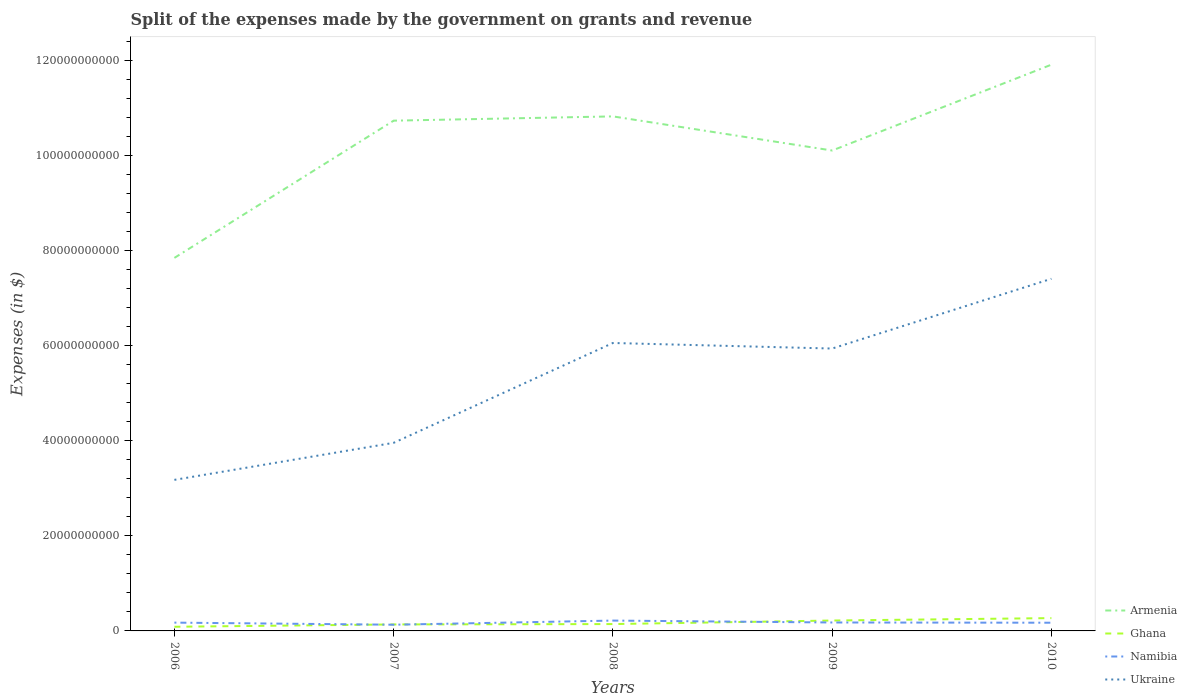Across all years, what is the maximum expenses made by the government on grants and revenue in Armenia?
Offer a very short reply. 7.84e+1. In which year was the expenses made by the government on grants and revenue in Armenia maximum?
Ensure brevity in your answer.  2006. What is the total expenses made by the government on grants and revenue in Ukraine in the graph?
Keep it short and to the point. -7.79e+09. What is the difference between the highest and the second highest expenses made by the government on grants and revenue in Namibia?
Make the answer very short. 8.70e+08. What is the difference between the highest and the lowest expenses made by the government on grants and revenue in Ukraine?
Provide a short and direct response. 3. Is the expenses made by the government on grants and revenue in Ghana strictly greater than the expenses made by the government on grants and revenue in Namibia over the years?
Make the answer very short. No. What is the difference between two consecutive major ticks on the Y-axis?
Offer a terse response. 2.00e+1. Does the graph contain any zero values?
Keep it short and to the point. No. How many legend labels are there?
Ensure brevity in your answer.  4. What is the title of the graph?
Offer a very short reply. Split of the expenses made by the government on grants and revenue. Does "Serbia" appear as one of the legend labels in the graph?
Offer a terse response. No. What is the label or title of the Y-axis?
Your response must be concise. Expenses (in $). What is the Expenses (in $) in Armenia in 2006?
Your response must be concise. 7.84e+1. What is the Expenses (in $) of Ghana in 2006?
Offer a very short reply. 8.75e+08. What is the Expenses (in $) in Namibia in 2006?
Keep it short and to the point. 1.75e+09. What is the Expenses (in $) in Ukraine in 2006?
Your response must be concise. 3.18e+1. What is the Expenses (in $) of Armenia in 2007?
Provide a succinct answer. 1.07e+11. What is the Expenses (in $) of Ghana in 2007?
Your response must be concise. 1.36e+09. What is the Expenses (in $) of Namibia in 2007?
Your response must be concise. 1.30e+09. What is the Expenses (in $) in Ukraine in 2007?
Keep it short and to the point. 3.95e+1. What is the Expenses (in $) of Armenia in 2008?
Keep it short and to the point. 1.08e+11. What is the Expenses (in $) in Ghana in 2008?
Make the answer very short. 1.44e+09. What is the Expenses (in $) in Namibia in 2008?
Give a very brief answer. 2.17e+09. What is the Expenses (in $) in Ukraine in 2008?
Your answer should be very brief. 6.05e+1. What is the Expenses (in $) in Armenia in 2009?
Give a very brief answer. 1.01e+11. What is the Expenses (in $) of Ghana in 2009?
Keep it short and to the point. 2.19e+09. What is the Expenses (in $) in Namibia in 2009?
Your response must be concise. 1.77e+09. What is the Expenses (in $) of Ukraine in 2009?
Keep it short and to the point. 5.94e+1. What is the Expenses (in $) of Armenia in 2010?
Keep it short and to the point. 1.19e+11. What is the Expenses (in $) in Ghana in 2010?
Make the answer very short. 2.69e+09. What is the Expenses (in $) in Namibia in 2010?
Your answer should be very brief. 1.72e+09. What is the Expenses (in $) in Ukraine in 2010?
Provide a succinct answer. 7.40e+1. Across all years, what is the maximum Expenses (in $) in Armenia?
Make the answer very short. 1.19e+11. Across all years, what is the maximum Expenses (in $) of Ghana?
Your answer should be compact. 2.69e+09. Across all years, what is the maximum Expenses (in $) in Namibia?
Provide a short and direct response. 2.17e+09. Across all years, what is the maximum Expenses (in $) in Ukraine?
Make the answer very short. 7.40e+1. Across all years, what is the minimum Expenses (in $) of Armenia?
Ensure brevity in your answer.  7.84e+1. Across all years, what is the minimum Expenses (in $) of Ghana?
Offer a very short reply. 8.75e+08. Across all years, what is the minimum Expenses (in $) in Namibia?
Ensure brevity in your answer.  1.30e+09. Across all years, what is the minimum Expenses (in $) of Ukraine?
Your response must be concise. 3.18e+1. What is the total Expenses (in $) in Armenia in the graph?
Provide a succinct answer. 5.14e+11. What is the total Expenses (in $) of Ghana in the graph?
Make the answer very short. 8.56e+09. What is the total Expenses (in $) in Namibia in the graph?
Ensure brevity in your answer.  8.72e+09. What is the total Expenses (in $) in Ukraine in the graph?
Give a very brief answer. 2.65e+11. What is the difference between the Expenses (in $) in Armenia in 2006 and that in 2007?
Provide a succinct answer. -2.89e+1. What is the difference between the Expenses (in $) in Ghana in 2006 and that in 2007?
Keep it short and to the point. -4.88e+08. What is the difference between the Expenses (in $) in Namibia in 2006 and that in 2007?
Keep it short and to the point. 4.41e+08. What is the difference between the Expenses (in $) of Ukraine in 2006 and that in 2007?
Make the answer very short. -7.79e+09. What is the difference between the Expenses (in $) in Armenia in 2006 and that in 2008?
Your answer should be very brief. -2.98e+1. What is the difference between the Expenses (in $) of Ghana in 2006 and that in 2008?
Ensure brevity in your answer.  -5.66e+08. What is the difference between the Expenses (in $) in Namibia in 2006 and that in 2008?
Provide a succinct answer. -4.29e+08. What is the difference between the Expenses (in $) in Ukraine in 2006 and that in 2008?
Offer a very short reply. -2.88e+1. What is the difference between the Expenses (in $) in Armenia in 2006 and that in 2009?
Offer a terse response. -2.26e+1. What is the difference between the Expenses (in $) in Ghana in 2006 and that in 2009?
Ensure brevity in your answer.  -1.31e+09. What is the difference between the Expenses (in $) in Namibia in 2006 and that in 2009?
Ensure brevity in your answer.  -2.82e+07. What is the difference between the Expenses (in $) of Ukraine in 2006 and that in 2009?
Keep it short and to the point. -2.76e+1. What is the difference between the Expenses (in $) in Armenia in 2006 and that in 2010?
Keep it short and to the point. -4.06e+1. What is the difference between the Expenses (in $) of Ghana in 2006 and that in 2010?
Your response must be concise. -1.82e+09. What is the difference between the Expenses (in $) in Namibia in 2006 and that in 2010?
Offer a terse response. 2.13e+07. What is the difference between the Expenses (in $) in Ukraine in 2006 and that in 2010?
Give a very brief answer. -4.23e+1. What is the difference between the Expenses (in $) of Armenia in 2007 and that in 2008?
Provide a short and direct response. -8.98e+08. What is the difference between the Expenses (in $) in Ghana in 2007 and that in 2008?
Offer a very short reply. -7.78e+07. What is the difference between the Expenses (in $) of Namibia in 2007 and that in 2008?
Offer a very short reply. -8.70e+08. What is the difference between the Expenses (in $) in Ukraine in 2007 and that in 2008?
Offer a terse response. -2.10e+1. What is the difference between the Expenses (in $) of Armenia in 2007 and that in 2009?
Provide a succinct answer. 6.28e+09. What is the difference between the Expenses (in $) of Ghana in 2007 and that in 2009?
Provide a short and direct response. -8.24e+08. What is the difference between the Expenses (in $) in Namibia in 2007 and that in 2009?
Provide a succinct answer. -4.69e+08. What is the difference between the Expenses (in $) of Ukraine in 2007 and that in 2009?
Provide a succinct answer. -1.98e+1. What is the difference between the Expenses (in $) of Armenia in 2007 and that in 2010?
Provide a succinct answer. -1.18e+1. What is the difference between the Expenses (in $) in Ghana in 2007 and that in 2010?
Provide a short and direct response. -1.33e+09. What is the difference between the Expenses (in $) in Namibia in 2007 and that in 2010?
Provide a succinct answer. -4.20e+08. What is the difference between the Expenses (in $) of Ukraine in 2007 and that in 2010?
Offer a terse response. -3.45e+1. What is the difference between the Expenses (in $) in Armenia in 2008 and that in 2009?
Offer a terse response. 7.18e+09. What is the difference between the Expenses (in $) in Ghana in 2008 and that in 2009?
Keep it short and to the point. -7.46e+08. What is the difference between the Expenses (in $) of Namibia in 2008 and that in 2009?
Provide a succinct answer. 4.01e+08. What is the difference between the Expenses (in $) of Ukraine in 2008 and that in 2009?
Make the answer very short. 1.17e+09. What is the difference between the Expenses (in $) in Armenia in 2008 and that in 2010?
Offer a terse response. -1.09e+1. What is the difference between the Expenses (in $) of Ghana in 2008 and that in 2010?
Your answer should be very brief. -1.25e+09. What is the difference between the Expenses (in $) in Namibia in 2008 and that in 2010?
Offer a terse response. 4.50e+08. What is the difference between the Expenses (in $) in Ukraine in 2008 and that in 2010?
Your answer should be very brief. -1.35e+1. What is the difference between the Expenses (in $) in Armenia in 2009 and that in 2010?
Give a very brief answer. -1.80e+1. What is the difference between the Expenses (in $) of Ghana in 2009 and that in 2010?
Make the answer very short. -5.08e+08. What is the difference between the Expenses (in $) in Namibia in 2009 and that in 2010?
Offer a very short reply. 4.94e+07. What is the difference between the Expenses (in $) in Ukraine in 2009 and that in 2010?
Your answer should be compact. -1.47e+1. What is the difference between the Expenses (in $) of Armenia in 2006 and the Expenses (in $) of Ghana in 2007?
Keep it short and to the point. 7.71e+1. What is the difference between the Expenses (in $) of Armenia in 2006 and the Expenses (in $) of Namibia in 2007?
Your answer should be very brief. 7.71e+1. What is the difference between the Expenses (in $) of Armenia in 2006 and the Expenses (in $) of Ukraine in 2007?
Offer a terse response. 3.89e+1. What is the difference between the Expenses (in $) of Ghana in 2006 and the Expenses (in $) of Namibia in 2007?
Provide a short and direct response. -4.30e+08. What is the difference between the Expenses (in $) in Ghana in 2006 and the Expenses (in $) in Ukraine in 2007?
Your answer should be very brief. -3.87e+1. What is the difference between the Expenses (in $) in Namibia in 2006 and the Expenses (in $) in Ukraine in 2007?
Make the answer very short. -3.78e+1. What is the difference between the Expenses (in $) of Armenia in 2006 and the Expenses (in $) of Ghana in 2008?
Your answer should be very brief. 7.70e+1. What is the difference between the Expenses (in $) of Armenia in 2006 and the Expenses (in $) of Namibia in 2008?
Offer a terse response. 7.63e+1. What is the difference between the Expenses (in $) of Armenia in 2006 and the Expenses (in $) of Ukraine in 2008?
Ensure brevity in your answer.  1.79e+1. What is the difference between the Expenses (in $) of Ghana in 2006 and the Expenses (in $) of Namibia in 2008?
Provide a short and direct response. -1.30e+09. What is the difference between the Expenses (in $) in Ghana in 2006 and the Expenses (in $) in Ukraine in 2008?
Your answer should be compact. -5.97e+1. What is the difference between the Expenses (in $) of Namibia in 2006 and the Expenses (in $) of Ukraine in 2008?
Your response must be concise. -5.88e+1. What is the difference between the Expenses (in $) of Armenia in 2006 and the Expenses (in $) of Ghana in 2009?
Provide a succinct answer. 7.62e+1. What is the difference between the Expenses (in $) of Armenia in 2006 and the Expenses (in $) of Namibia in 2009?
Ensure brevity in your answer.  7.67e+1. What is the difference between the Expenses (in $) of Armenia in 2006 and the Expenses (in $) of Ukraine in 2009?
Ensure brevity in your answer.  1.91e+1. What is the difference between the Expenses (in $) in Ghana in 2006 and the Expenses (in $) in Namibia in 2009?
Offer a very short reply. -8.99e+08. What is the difference between the Expenses (in $) in Ghana in 2006 and the Expenses (in $) in Ukraine in 2009?
Your answer should be very brief. -5.85e+1. What is the difference between the Expenses (in $) in Namibia in 2006 and the Expenses (in $) in Ukraine in 2009?
Your response must be concise. -5.76e+1. What is the difference between the Expenses (in $) in Armenia in 2006 and the Expenses (in $) in Ghana in 2010?
Ensure brevity in your answer.  7.57e+1. What is the difference between the Expenses (in $) of Armenia in 2006 and the Expenses (in $) of Namibia in 2010?
Offer a very short reply. 7.67e+1. What is the difference between the Expenses (in $) in Armenia in 2006 and the Expenses (in $) in Ukraine in 2010?
Your answer should be compact. 4.39e+09. What is the difference between the Expenses (in $) in Ghana in 2006 and the Expenses (in $) in Namibia in 2010?
Provide a short and direct response. -8.50e+08. What is the difference between the Expenses (in $) in Ghana in 2006 and the Expenses (in $) in Ukraine in 2010?
Ensure brevity in your answer.  -7.32e+1. What is the difference between the Expenses (in $) in Namibia in 2006 and the Expenses (in $) in Ukraine in 2010?
Offer a terse response. -7.23e+1. What is the difference between the Expenses (in $) in Armenia in 2007 and the Expenses (in $) in Ghana in 2008?
Ensure brevity in your answer.  1.06e+11. What is the difference between the Expenses (in $) in Armenia in 2007 and the Expenses (in $) in Namibia in 2008?
Make the answer very short. 1.05e+11. What is the difference between the Expenses (in $) in Armenia in 2007 and the Expenses (in $) in Ukraine in 2008?
Your response must be concise. 4.67e+1. What is the difference between the Expenses (in $) of Ghana in 2007 and the Expenses (in $) of Namibia in 2008?
Make the answer very short. -8.12e+08. What is the difference between the Expenses (in $) of Ghana in 2007 and the Expenses (in $) of Ukraine in 2008?
Your response must be concise. -5.92e+1. What is the difference between the Expenses (in $) of Namibia in 2007 and the Expenses (in $) of Ukraine in 2008?
Give a very brief answer. -5.92e+1. What is the difference between the Expenses (in $) of Armenia in 2007 and the Expenses (in $) of Ghana in 2009?
Your answer should be very brief. 1.05e+11. What is the difference between the Expenses (in $) in Armenia in 2007 and the Expenses (in $) in Namibia in 2009?
Your answer should be compact. 1.06e+11. What is the difference between the Expenses (in $) of Armenia in 2007 and the Expenses (in $) of Ukraine in 2009?
Make the answer very short. 4.79e+1. What is the difference between the Expenses (in $) in Ghana in 2007 and the Expenses (in $) in Namibia in 2009?
Your answer should be compact. -4.11e+08. What is the difference between the Expenses (in $) in Ghana in 2007 and the Expenses (in $) in Ukraine in 2009?
Offer a terse response. -5.80e+1. What is the difference between the Expenses (in $) of Namibia in 2007 and the Expenses (in $) of Ukraine in 2009?
Make the answer very short. -5.81e+1. What is the difference between the Expenses (in $) of Armenia in 2007 and the Expenses (in $) of Ghana in 2010?
Your response must be concise. 1.05e+11. What is the difference between the Expenses (in $) in Armenia in 2007 and the Expenses (in $) in Namibia in 2010?
Your response must be concise. 1.06e+11. What is the difference between the Expenses (in $) in Armenia in 2007 and the Expenses (in $) in Ukraine in 2010?
Offer a terse response. 3.32e+1. What is the difference between the Expenses (in $) of Ghana in 2007 and the Expenses (in $) of Namibia in 2010?
Provide a succinct answer. -3.61e+08. What is the difference between the Expenses (in $) of Ghana in 2007 and the Expenses (in $) of Ukraine in 2010?
Offer a very short reply. -7.27e+1. What is the difference between the Expenses (in $) in Namibia in 2007 and the Expenses (in $) in Ukraine in 2010?
Offer a very short reply. -7.27e+1. What is the difference between the Expenses (in $) in Armenia in 2008 and the Expenses (in $) in Ghana in 2009?
Your answer should be very brief. 1.06e+11. What is the difference between the Expenses (in $) of Armenia in 2008 and the Expenses (in $) of Namibia in 2009?
Ensure brevity in your answer.  1.06e+11. What is the difference between the Expenses (in $) in Armenia in 2008 and the Expenses (in $) in Ukraine in 2009?
Your answer should be compact. 4.88e+1. What is the difference between the Expenses (in $) of Ghana in 2008 and the Expenses (in $) of Namibia in 2009?
Offer a very short reply. -3.33e+08. What is the difference between the Expenses (in $) in Ghana in 2008 and the Expenses (in $) in Ukraine in 2009?
Your answer should be compact. -5.79e+1. What is the difference between the Expenses (in $) of Namibia in 2008 and the Expenses (in $) of Ukraine in 2009?
Keep it short and to the point. -5.72e+1. What is the difference between the Expenses (in $) in Armenia in 2008 and the Expenses (in $) in Ghana in 2010?
Ensure brevity in your answer.  1.05e+11. What is the difference between the Expenses (in $) of Armenia in 2008 and the Expenses (in $) of Namibia in 2010?
Your answer should be compact. 1.06e+11. What is the difference between the Expenses (in $) of Armenia in 2008 and the Expenses (in $) of Ukraine in 2010?
Provide a short and direct response. 3.41e+1. What is the difference between the Expenses (in $) of Ghana in 2008 and the Expenses (in $) of Namibia in 2010?
Offer a terse response. -2.83e+08. What is the difference between the Expenses (in $) in Ghana in 2008 and the Expenses (in $) in Ukraine in 2010?
Provide a succinct answer. -7.26e+1. What is the difference between the Expenses (in $) of Namibia in 2008 and the Expenses (in $) of Ukraine in 2010?
Your response must be concise. -7.19e+1. What is the difference between the Expenses (in $) of Armenia in 2009 and the Expenses (in $) of Ghana in 2010?
Keep it short and to the point. 9.83e+1. What is the difference between the Expenses (in $) in Armenia in 2009 and the Expenses (in $) in Namibia in 2010?
Your answer should be very brief. 9.93e+1. What is the difference between the Expenses (in $) in Armenia in 2009 and the Expenses (in $) in Ukraine in 2010?
Provide a short and direct response. 2.70e+1. What is the difference between the Expenses (in $) of Ghana in 2009 and the Expenses (in $) of Namibia in 2010?
Your answer should be very brief. 4.62e+08. What is the difference between the Expenses (in $) of Ghana in 2009 and the Expenses (in $) of Ukraine in 2010?
Your response must be concise. -7.19e+1. What is the difference between the Expenses (in $) of Namibia in 2009 and the Expenses (in $) of Ukraine in 2010?
Provide a short and direct response. -7.23e+1. What is the average Expenses (in $) in Armenia per year?
Offer a very short reply. 1.03e+11. What is the average Expenses (in $) of Ghana per year?
Your answer should be compact. 1.71e+09. What is the average Expenses (in $) in Namibia per year?
Offer a very short reply. 1.74e+09. What is the average Expenses (in $) of Ukraine per year?
Make the answer very short. 5.31e+1. In the year 2006, what is the difference between the Expenses (in $) in Armenia and Expenses (in $) in Ghana?
Offer a terse response. 7.76e+1. In the year 2006, what is the difference between the Expenses (in $) of Armenia and Expenses (in $) of Namibia?
Give a very brief answer. 7.67e+1. In the year 2006, what is the difference between the Expenses (in $) of Armenia and Expenses (in $) of Ukraine?
Make the answer very short. 4.67e+1. In the year 2006, what is the difference between the Expenses (in $) of Ghana and Expenses (in $) of Namibia?
Provide a succinct answer. -8.71e+08. In the year 2006, what is the difference between the Expenses (in $) of Ghana and Expenses (in $) of Ukraine?
Make the answer very short. -3.09e+1. In the year 2006, what is the difference between the Expenses (in $) in Namibia and Expenses (in $) in Ukraine?
Offer a very short reply. -3.00e+1. In the year 2007, what is the difference between the Expenses (in $) in Armenia and Expenses (in $) in Ghana?
Provide a short and direct response. 1.06e+11. In the year 2007, what is the difference between the Expenses (in $) in Armenia and Expenses (in $) in Namibia?
Provide a short and direct response. 1.06e+11. In the year 2007, what is the difference between the Expenses (in $) of Armenia and Expenses (in $) of Ukraine?
Make the answer very short. 6.77e+1. In the year 2007, what is the difference between the Expenses (in $) of Ghana and Expenses (in $) of Namibia?
Provide a succinct answer. 5.83e+07. In the year 2007, what is the difference between the Expenses (in $) of Ghana and Expenses (in $) of Ukraine?
Your answer should be very brief. -3.82e+1. In the year 2007, what is the difference between the Expenses (in $) of Namibia and Expenses (in $) of Ukraine?
Give a very brief answer. -3.82e+1. In the year 2008, what is the difference between the Expenses (in $) of Armenia and Expenses (in $) of Ghana?
Provide a short and direct response. 1.07e+11. In the year 2008, what is the difference between the Expenses (in $) in Armenia and Expenses (in $) in Namibia?
Ensure brevity in your answer.  1.06e+11. In the year 2008, what is the difference between the Expenses (in $) of Armenia and Expenses (in $) of Ukraine?
Your answer should be very brief. 4.76e+1. In the year 2008, what is the difference between the Expenses (in $) in Ghana and Expenses (in $) in Namibia?
Keep it short and to the point. -7.34e+08. In the year 2008, what is the difference between the Expenses (in $) of Ghana and Expenses (in $) of Ukraine?
Offer a terse response. -5.91e+1. In the year 2008, what is the difference between the Expenses (in $) in Namibia and Expenses (in $) in Ukraine?
Make the answer very short. -5.84e+1. In the year 2009, what is the difference between the Expenses (in $) of Armenia and Expenses (in $) of Ghana?
Give a very brief answer. 9.88e+1. In the year 2009, what is the difference between the Expenses (in $) of Armenia and Expenses (in $) of Namibia?
Your answer should be very brief. 9.92e+1. In the year 2009, what is the difference between the Expenses (in $) in Armenia and Expenses (in $) in Ukraine?
Give a very brief answer. 4.16e+1. In the year 2009, what is the difference between the Expenses (in $) of Ghana and Expenses (in $) of Namibia?
Your response must be concise. 4.13e+08. In the year 2009, what is the difference between the Expenses (in $) in Ghana and Expenses (in $) in Ukraine?
Your answer should be very brief. -5.72e+1. In the year 2009, what is the difference between the Expenses (in $) of Namibia and Expenses (in $) of Ukraine?
Give a very brief answer. -5.76e+1. In the year 2010, what is the difference between the Expenses (in $) in Armenia and Expenses (in $) in Ghana?
Provide a succinct answer. 1.16e+11. In the year 2010, what is the difference between the Expenses (in $) of Armenia and Expenses (in $) of Namibia?
Provide a succinct answer. 1.17e+11. In the year 2010, what is the difference between the Expenses (in $) in Armenia and Expenses (in $) in Ukraine?
Provide a short and direct response. 4.50e+1. In the year 2010, what is the difference between the Expenses (in $) in Ghana and Expenses (in $) in Namibia?
Make the answer very short. 9.70e+08. In the year 2010, what is the difference between the Expenses (in $) of Ghana and Expenses (in $) of Ukraine?
Ensure brevity in your answer.  -7.13e+1. In the year 2010, what is the difference between the Expenses (in $) of Namibia and Expenses (in $) of Ukraine?
Offer a terse response. -7.23e+1. What is the ratio of the Expenses (in $) of Armenia in 2006 to that in 2007?
Your answer should be very brief. 0.73. What is the ratio of the Expenses (in $) in Ghana in 2006 to that in 2007?
Ensure brevity in your answer.  0.64. What is the ratio of the Expenses (in $) of Namibia in 2006 to that in 2007?
Offer a terse response. 1.34. What is the ratio of the Expenses (in $) in Ukraine in 2006 to that in 2007?
Offer a very short reply. 0.8. What is the ratio of the Expenses (in $) of Armenia in 2006 to that in 2008?
Offer a very short reply. 0.72. What is the ratio of the Expenses (in $) of Ghana in 2006 to that in 2008?
Give a very brief answer. 0.61. What is the ratio of the Expenses (in $) in Namibia in 2006 to that in 2008?
Keep it short and to the point. 0.8. What is the ratio of the Expenses (in $) of Ukraine in 2006 to that in 2008?
Provide a short and direct response. 0.52. What is the ratio of the Expenses (in $) in Armenia in 2006 to that in 2009?
Give a very brief answer. 0.78. What is the ratio of the Expenses (in $) of Ghana in 2006 to that in 2009?
Provide a succinct answer. 0.4. What is the ratio of the Expenses (in $) in Namibia in 2006 to that in 2009?
Provide a succinct answer. 0.98. What is the ratio of the Expenses (in $) of Ukraine in 2006 to that in 2009?
Your answer should be very brief. 0.54. What is the ratio of the Expenses (in $) of Armenia in 2006 to that in 2010?
Your answer should be very brief. 0.66. What is the ratio of the Expenses (in $) of Ghana in 2006 to that in 2010?
Your response must be concise. 0.32. What is the ratio of the Expenses (in $) in Namibia in 2006 to that in 2010?
Make the answer very short. 1.01. What is the ratio of the Expenses (in $) of Ukraine in 2006 to that in 2010?
Provide a short and direct response. 0.43. What is the ratio of the Expenses (in $) in Armenia in 2007 to that in 2008?
Ensure brevity in your answer.  0.99. What is the ratio of the Expenses (in $) of Ghana in 2007 to that in 2008?
Provide a short and direct response. 0.95. What is the ratio of the Expenses (in $) in Ukraine in 2007 to that in 2008?
Make the answer very short. 0.65. What is the ratio of the Expenses (in $) of Armenia in 2007 to that in 2009?
Your response must be concise. 1.06. What is the ratio of the Expenses (in $) of Ghana in 2007 to that in 2009?
Your response must be concise. 0.62. What is the ratio of the Expenses (in $) of Namibia in 2007 to that in 2009?
Your answer should be very brief. 0.74. What is the ratio of the Expenses (in $) of Ukraine in 2007 to that in 2009?
Your response must be concise. 0.67. What is the ratio of the Expenses (in $) in Armenia in 2007 to that in 2010?
Provide a short and direct response. 0.9. What is the ratio of the Expenses (in $) of Ghana in 2007 to that in 2010?
Provide a short and direct response. 0.51. What is the ratio of the Expenses (in $) of Namibia in 2007 to that in 2010?
Your response must be concise. 0.76. What is the ratio of the Expenses (in $) in Ukraine in 2007 to that in 2010?
Keep it short and to the point. 0.53. What is the ratio of the Expenses (in $) in Armenia in 2008 to that in 2009?
Offer a terse response. 1.07. What is the ratio of the Expenses (in $) in Ghana in 2008 to that in 2009?
Make the answer very short. 0.66. What is the ratio of the Expenses (in $) in Namibia in 2008 to that in 2009?
Give a very brief answer. 1.23. What is the ratio of the Expenses (in $) in Ukraine in 2008 to that in 2009?
Your answer should be compact. 1.02. What is the ratio of the Expenses (in $) in Armenia in 2008 to that in 2010?
Offer a very short reply. 0.91. What is the ratio of the Expenses (in $) of Ghana in 2008 to that in 2010?
Your answer should be very brief. 0.53. What is the ratio of the Expenses (in $) of Namibia in 2008 to that in 2010?
Give a very brief answer. 1.26. What is the ratio of the Expenses (in $) of Ukraine in 2008 to that in 2010?
Your answer should be very brief. 0.82. What is the ratio of the Expenses (in $) of Armenia in 2009 to that in 2010?
Your answer should be compact. 0.85. What is the ratio of the Expenses (in $) of Ghana in 2009 to that in 2010?
Ensure brevity in your answer.  0.81. What is the ratio of the Expenses (in $) in Namibia in 2009 to that in 2010?
Keep it short and to the point. 1.03. What is the ratio of the Expenses (in $) of Ukraine in 2009 to that in 2010?
Offer a very short reply. 0.8. What is the difference between the highest and the second highest Expenses (in $) of Armenia?
Your answer should be very brief. 1.09e+1. What is the difference between the highest and the second highest Expenses (in $) in Ghana?
Provide a succinct answer. 5.08e+08. What is the difference between the highest and the second highest Expenses (in $) of Namibia?
Ensure brevity in your answer.  4.01e+08. What is the difference between the highest and the second highest Expenses (in $) in Ukraine?
Give a very brief answer. 1.35e+1. What is the difference between the highest and the lowest Expenses (in $) of Armenia?
Give a very brief answer. 4.06e+1. What is the difference between the highest and the lowest Expenses (in $) in Ghana?
Offer a very short reply. 1.82e+09. What is the difference between the highest and the lowest Expenses (in $) in Namibia?
Provide a succinct answer. 8.70e+08. What is the difference between the highest and the lowest Expenses (in $) in Ukraine?
Your answer should be compact. 4.23e+1. 